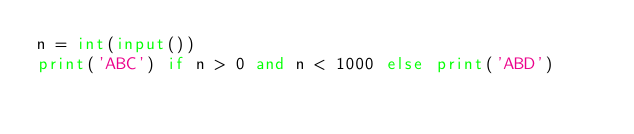Convert code to text. <code><loc_0><loc_0><loc_500><loc_500><_Python_>n = int(input())
print('ABC') if n > 0 and n < 1000 else print('ABD')</code> 